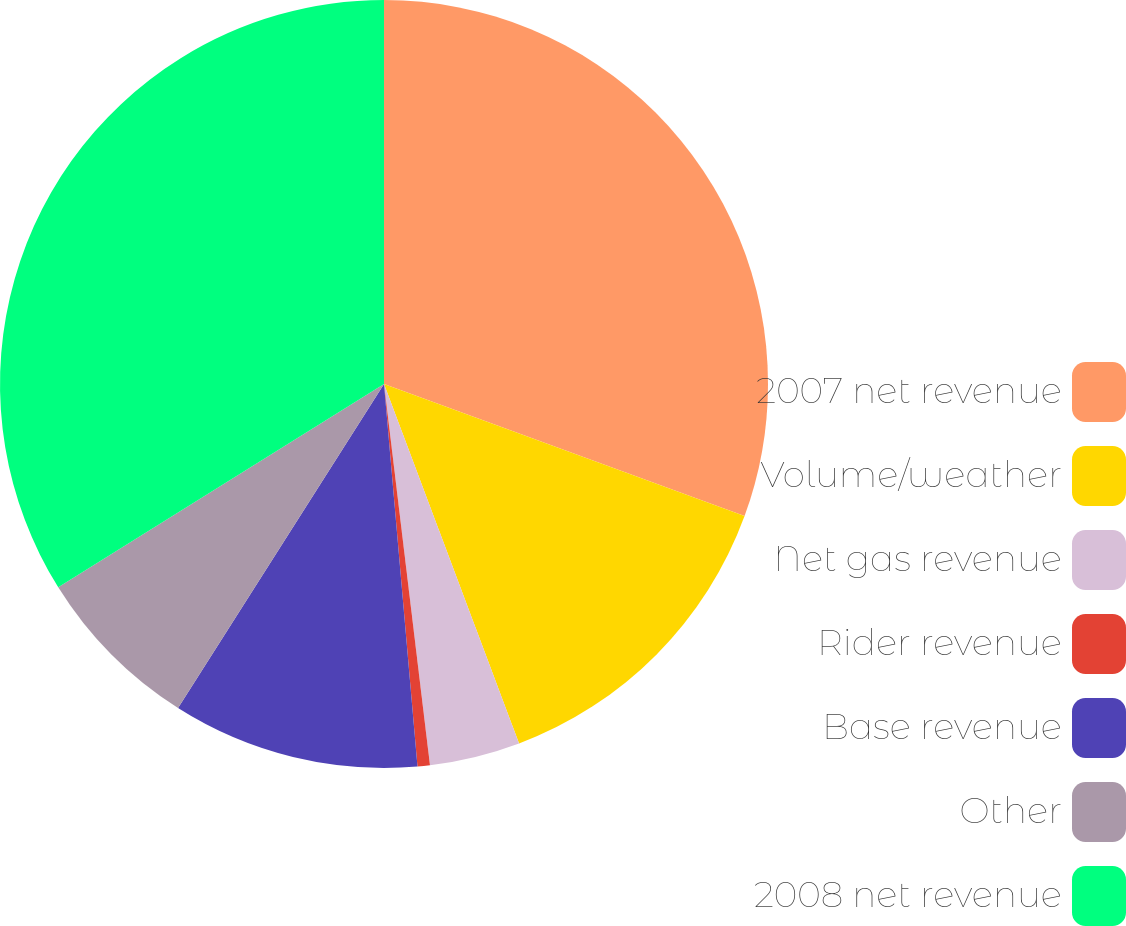Convert chart. <chart><loc_0><loc_0><loc_500><loc_500><pie_chart><fcel>2007 net revenue<fcel>Volume/weather<fcel>Net gas revenue<fcel>Rider revenue<fcel>Base revenue<fcel>Other<fcel>2008 net revenue<nl><fcel>30.59%<fcel>13.69%<fcel>3.81%<fcel>0.52%<fcel>10.4%<fcel>7.11%<fcel>33.88%<nl></chart> 